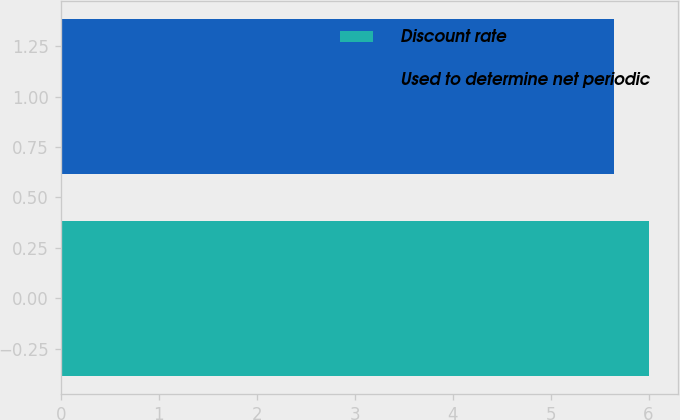Convert chart. <chart><loc_0><loc_0><loc_500><loc_500><bar_chart><fcel>Discount rate<fcel>Used to determine net periodic<nl><fcel>6<fcel>5.65<nl></chart> 